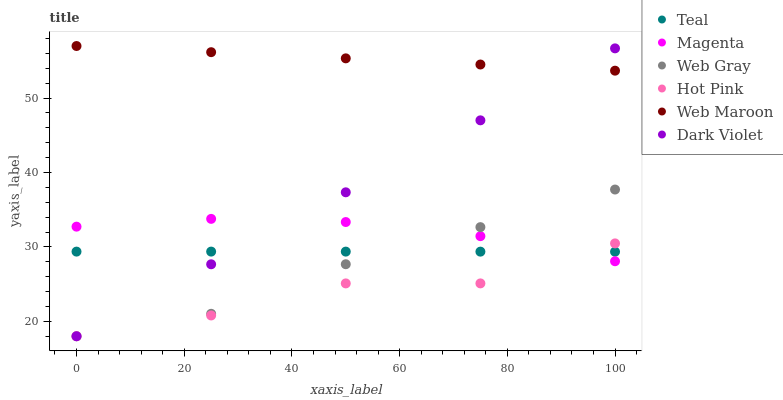Does Hot Pink have the minimum area under the curve?
Answer yes or no. Yes. Does Web Maroon have the maximum area under the curve?
Answer yes or no. Yes. Does Web Maroon have the minimum area under the curve?
Answer yes or no. No. Does Hot Pink have the maximum area under the curve?
Answer yes or no. No. Is Web Maroon the smoothest?
Answer yes or no. Yes. Is Hot Pink the roughest?
Answer yes or no. Yes. Is Hot Pink the smoothest?
Answer yes or no. No. Is Web Maroon the roughest?
Answer yes or no. No. Does Web Gray have the lowest value?
Answer yes or no. Yes. Does Web Maroon have the lowest value?
Answer yes or no. No. Does Web Maroon have the highest value?
Answer yes or no. Yes. Does Hot Pink have the highest value?
Answer yes or no. No. Is Hot Pink less than Web Maroon?
Answer yes or no. Yes. Is Web Maroon greater than Hot Pink?
Answer yes or no. Yes. Does Hot Pink intersect Teal?
Answer yes or no. Yes. Is Hot Pink less than Teal?
Answer yes or no. No. Is Hot Pink greater than Teal?
Answer yes or no. No. Does Hot Pink intersect Web Maroon?
Answer yes or no. No. 